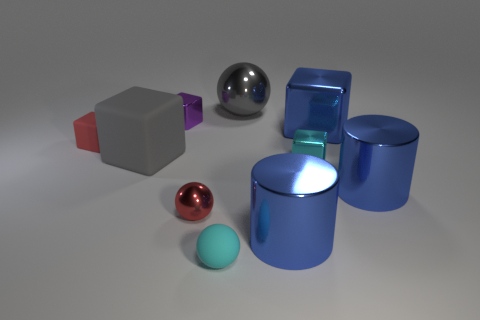What is the largest object in the image? The largest object in the image is the blue metallic cylinder on the right side, which has a reflective surface and stands out due to its size. 